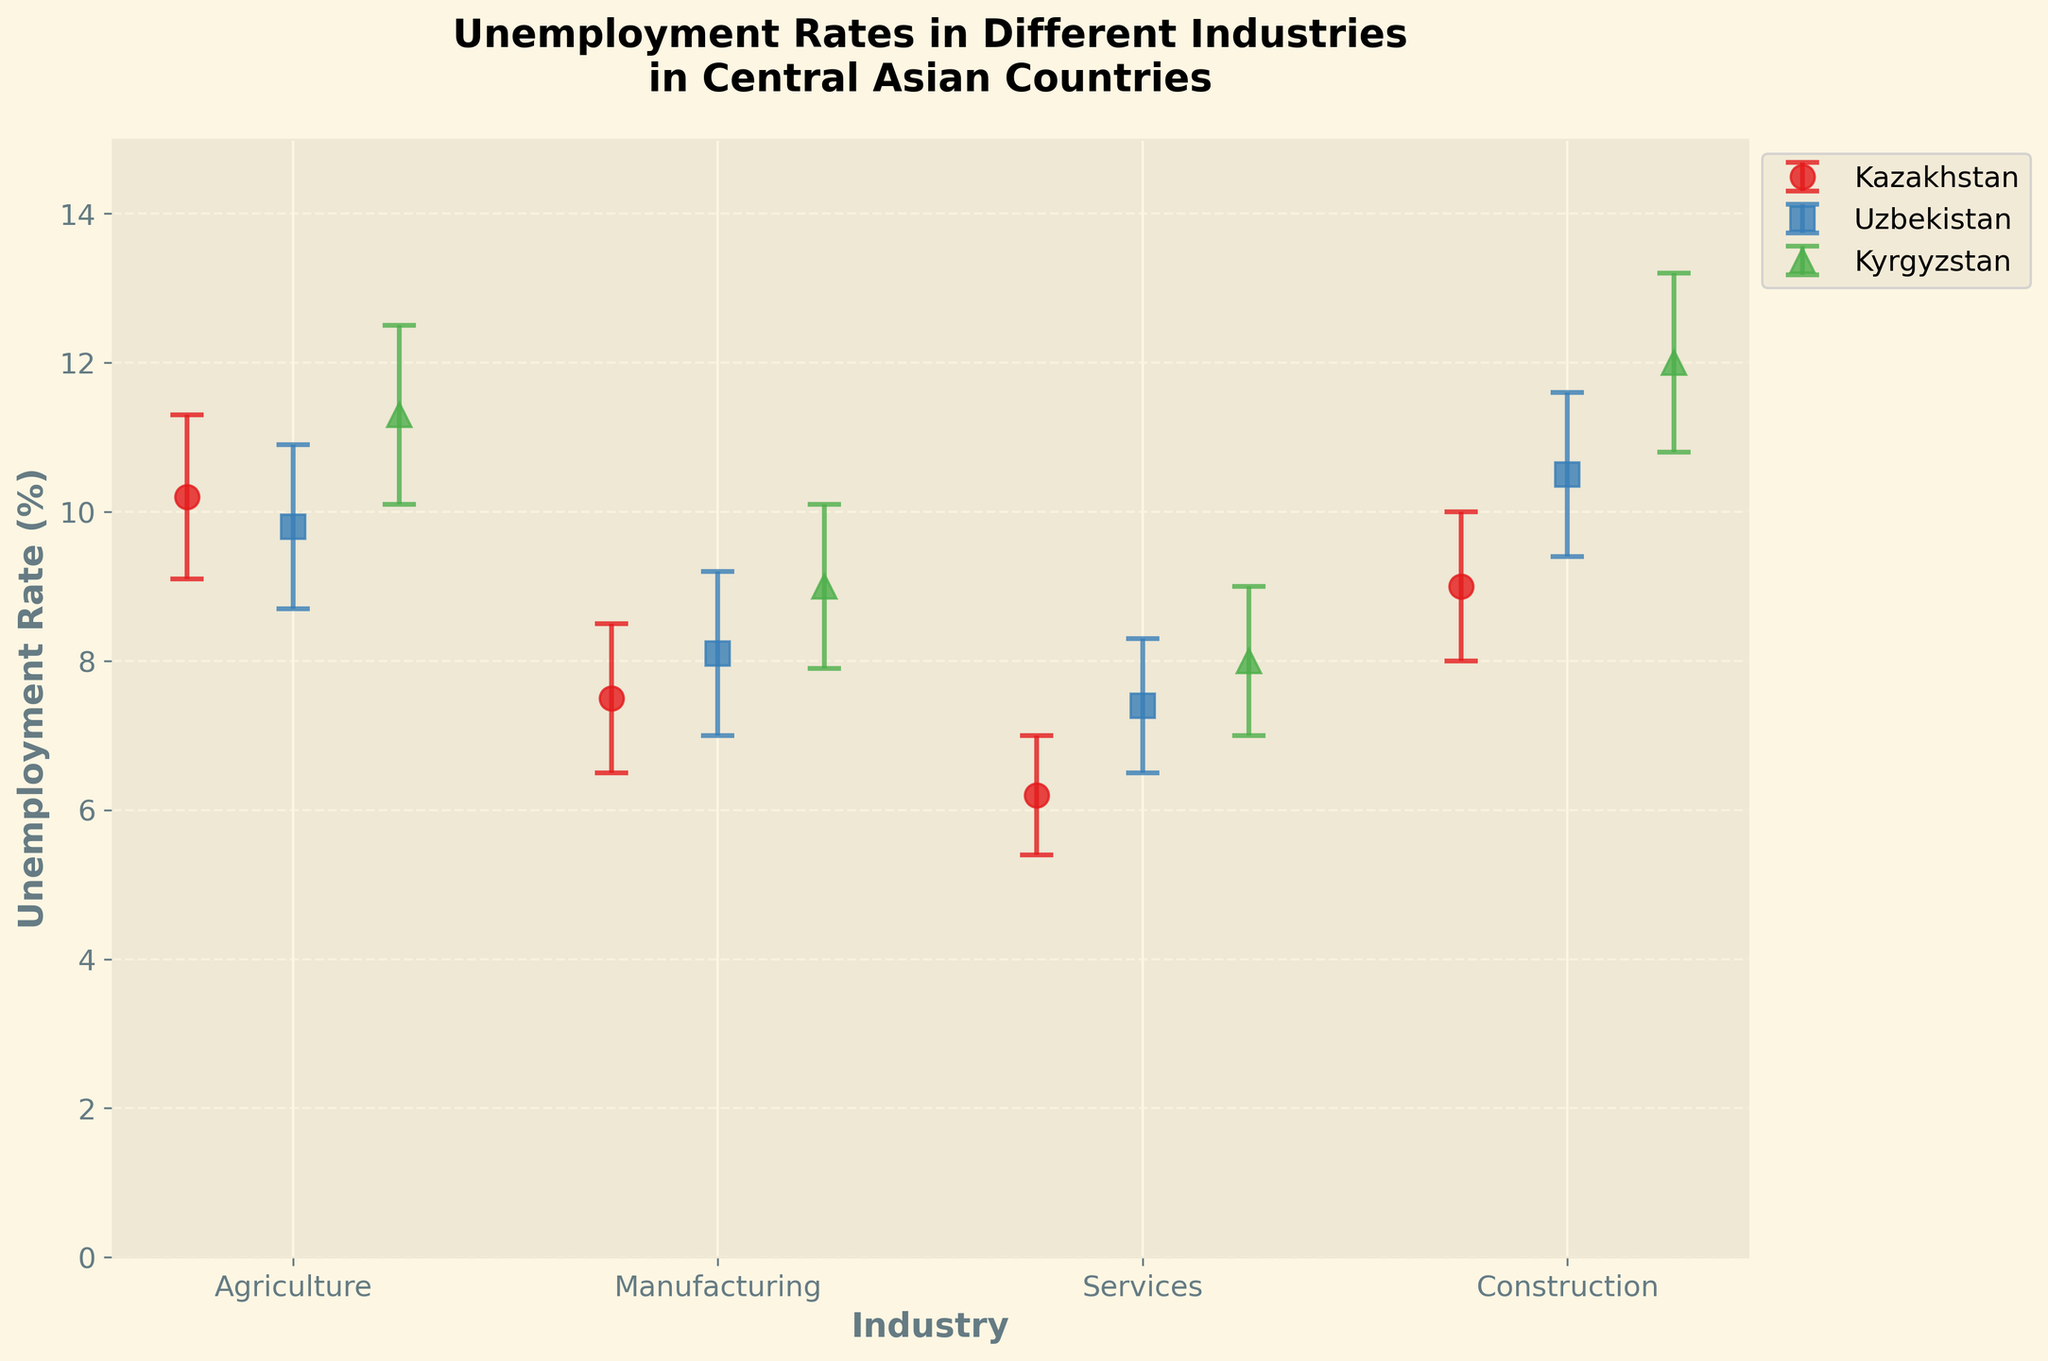Which industry has the highest unemployment rate in Kyrgyzstan? Looking at the dot plot, find the highest unemployment rate for Kyrgyzstan across different industries. The highest unemployment rate is in the Construction industry at 12.0%, with error bars indicating confidence intervals from 10.8% to 13.2%.
Answer: Construction What is the range of unemployment rates in the Agriculture industry across all three countries? Identify the minimum and maximum unemployment rates in Agriculture for Kazakhstan, Uzbekistan, and Kyrgyzstan. For Kazakhstan, it is 10.2%, for Uzbekistan 9.8%, and for Kyrgyzstan 11.3%. The range is from 9.8% to 11.3%.
Answer: 9.8% to 11.3% How does the unemployment rate in the Manufacturing sector of Kazakhstan compare to Uzbekistan? Compare the unemployment rates for the Manufacturing sector in Kazakhstan and Uzbekistan. Kazakhstan's rate is 7.5% [6.5%, 8.5%], whereas Uzbekistan's rate is 8.1% [7.0%, 9.2%].
Answer: Kazakhstan is lower What is the average unemployment rate in the Services industry across all three countries? Find the unemployment rates in the Services industry for Kazakhstan (6.2%), Uzbekistan (7.4%), and Kyrgyzstan (8.0%). Calculate the average by summing these values and dividing by 3: (6.2 + 7.4 + 8.0) / 3 = 7.2.
Answer: 7.2% Which country has the smallest confidence interval in the Agriculture industry? Evaluate the confidence intervals in the Agriculture industry for Kazakhstan ([9.1%, 11.3%]), Uzbekistan ([8.7%, 10.9%]), and Kyrgyzstan ([10.1%, 12.5%]). The smallest interval is Uzbekistan's at 2.2%.
Answer: Uzbekistan What is the difference in the unemployment rate between the Manufacturing and Services sectors in Kazakhstan? Look at the unemployment rates for the Manufacturing (7.5%) and Services (6.2%) sectors in Kazakhstan and calculate the difference: 7.5% - 6.2% = 1.3%.
Answer: 1.3% In which industry does Uzbekistan have the highest unemployment rate? Examine the unemployment rates in Uzbekistan across different industries. The highest rate is in the Construction industry at 10.5% with error bars [9.4%, 11.6%].
Answer: Construction What is the combined confidence interval range of Agriculture and Manufacturing industries in Uzbekistan? Identify the confidence intervals for Agriculture ([8.7%, 10.9%]) and Manufacturing ([7.0%, 9.2%]) in Uzbekistan and combine the ranges. The combined range is from the minimum of 7.0% to the maximum of 10.9%.
Answer: 7.0% to 10.9% Which industry shows the most significant variation in unemployment rates among the three countries? Compare the ranges of unemployment rates for each industry across Kazakhstan, Uzbekistan, and Kyrgyzstan. The most significant variation is in the Construction industry, with rates ranging from 9.0% to 12.0%.
Answer: Construction 